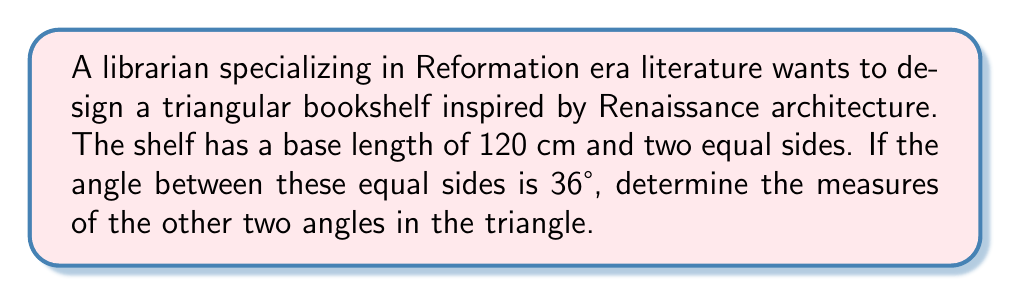Teach me how to tackle this problem. Let's approach this step-by-step:

1) First, we recognize that this is an isosceles triangle, as two sides are equal.

2) In an isosceles triangle, the angles opposite the equal sides are also equal. Let's call each of these angles $x$.

3) We know that the sum of angles in a triangle is always 180°. So we can set up the equation:

   $$x + x + 36° = 180°$$

4) Simplify:
   $$2x + 36° = 180°$$

5) Subtract 36° from both sides:
   $$2x = 144°$$

6) Divide both sides by 2:
   $$x = 72°$$

7) Therefore, the two equal angles are each 72°.

[asy]
import geometry;

size(200);

pair A = (0,0), B = (120,0), C = (60,103.92);

draw(A--B--C--A);

label("120 cm", (60,-10), S);
label("72°", (10,20), NW);
label("72°", (110,20), NE);
label("36°", (60,90), N);

dot("A", A, SW);
dot("B", B, SE);
dot("C", C, N);
[/asy]
Answer: 72°, 72°, 36° 